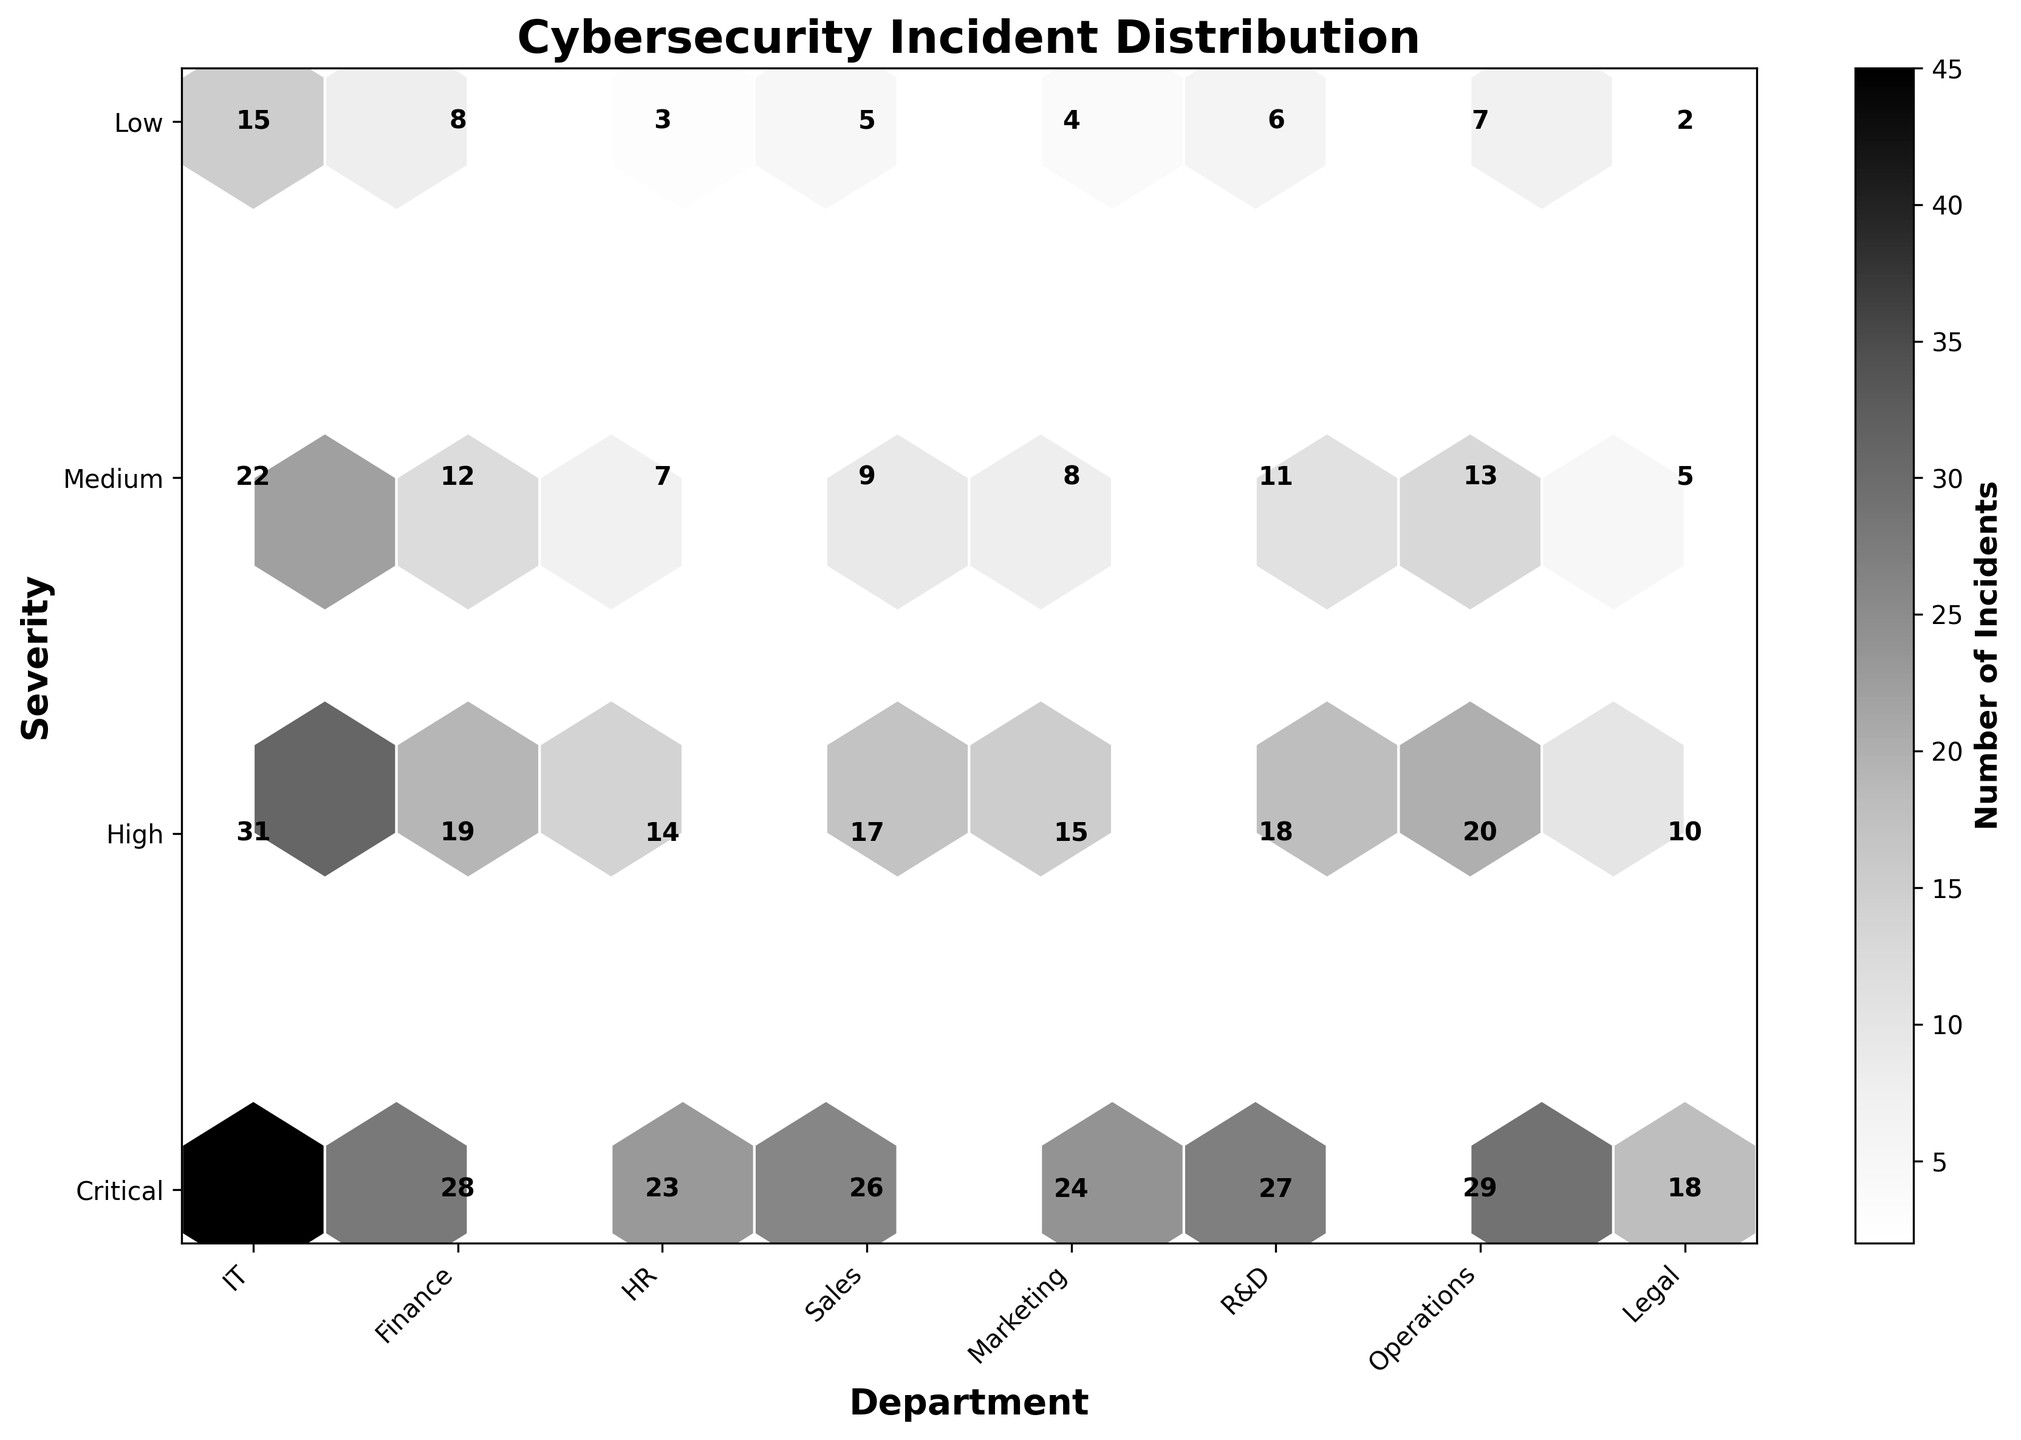What is the title of the plot? The plot's title is usually displayed prominently at the top of the figure. In this case, it is clearly mentioned in the provided code.
Answer: Cybersecurity Incident Distribution Which department has the highest number of 'Critical' severity incidents? Each hexagon's color intensity represents the number of incidents. The code also annotates the exact count of incidents for clarity. The darkest hexagon in the 'Critical' row should be checked.
Answer: IT (15 incidents) What is the total number of incidents in the Finance department? Add up the incidents from the Finance row across all severity levels: 8 (Critical) + 12 (High) + 19 (Medium) + 28 (Low).
Answer: 67 Which department has fewer incidents overall, HR or Sales? Sum the incidents for HR: 3 (Critical) + 7 (High) + 14 (Medium) + 23 (Low) = 47. Sum the incidents for Sales: 5 (Critical) + 9 (High) + 17 (Medium) + 26 (Low) = 57. Compare the totals.
Answer: HR In terms of 'Low' severity incidents, which department has the second-highest count? The provided plot annotations can be used to find the count of 'Low' severity incidents for each department. The second-highest value should be identified after the highest.
Answer: Operations (29 incidents) Among 'Critical' severity incidents, which two departments have the lowest counts? The plot annotations will reveal the counts for 'Critical' severity incidents across all departments. Identify the two with the lowest counts.
Answer: Legal (2) and HR (3) Does the Marketing department have more 'High' or 'Medium' severity incidents? Compare the hexagons in the Marketing row for 'High' and 'Medium' severity levels by looking at their annotations.
Answer: Medium (15 incidents) 